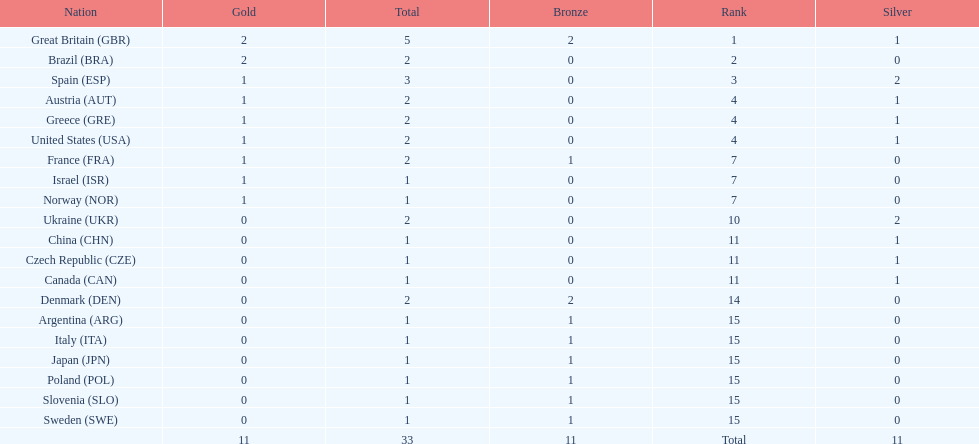What nation was next to great britain in total medal count? Spain. 